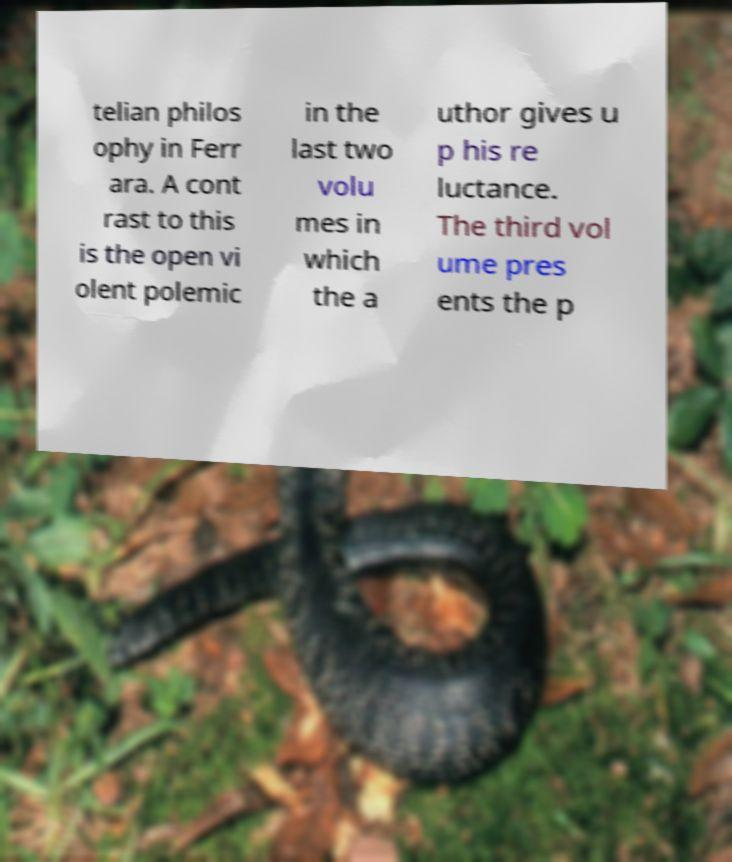Please read and relay the text visible in this image. What does it say? telian philos ophy in Ferr ara. A cont rast to this is the open vi olent polemic in the last two volu mes in which the a uthor gives u p his re luctance. The third vol ume pres ents the p 